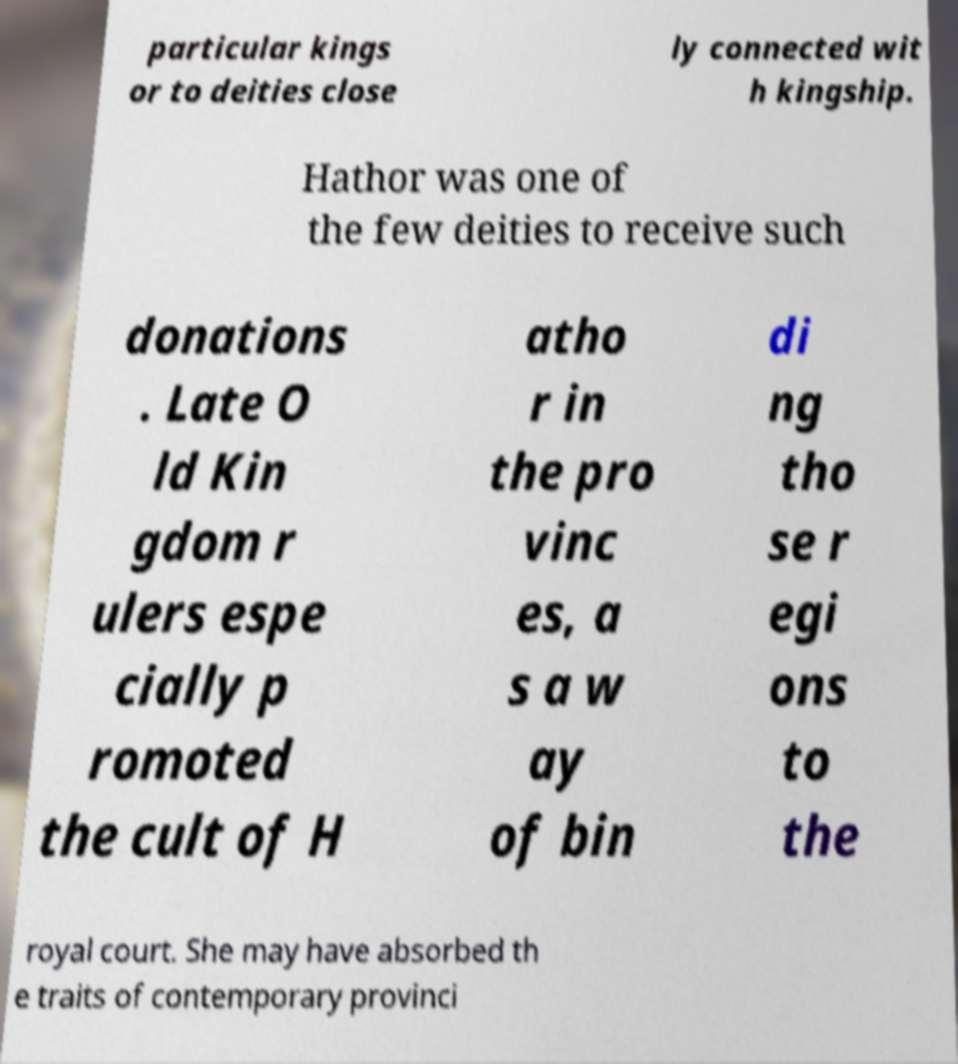Could you extract and type out the text from this image? particular kings or to deities close ly connected wit h kingship. Hathor was one of the few deities to receive such donations . Late O ld Kin gdom r ulers espe cially p romoted the cult of H atho r in the pro vinc es, a s a w ay of bin di ng tho se r egi ons to the royal court. She may have absorbed th e traits of contemporary provinci 